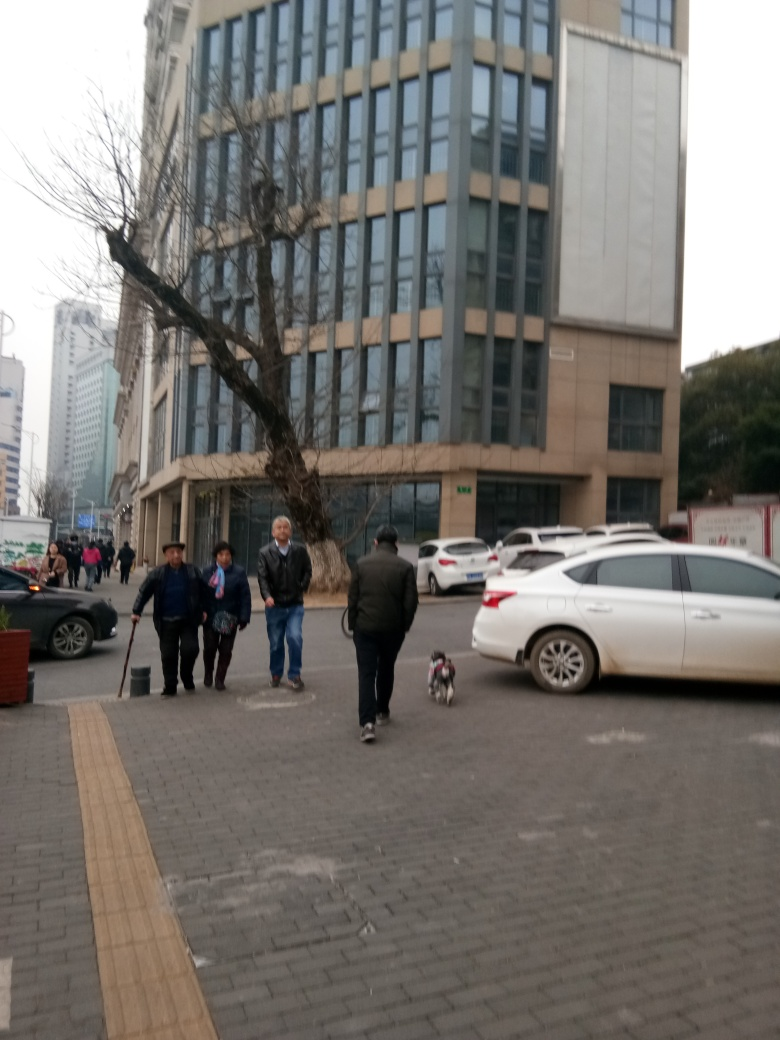What could be the purpose of the people's gathering in the picture? The image seems to capture a moment on a city street where people are engaging in everyday activities. There is no indication of a special event; rather, it appears that some individuals are going about their daily routines while the person with the broom might be cleaning the sidewalk. 